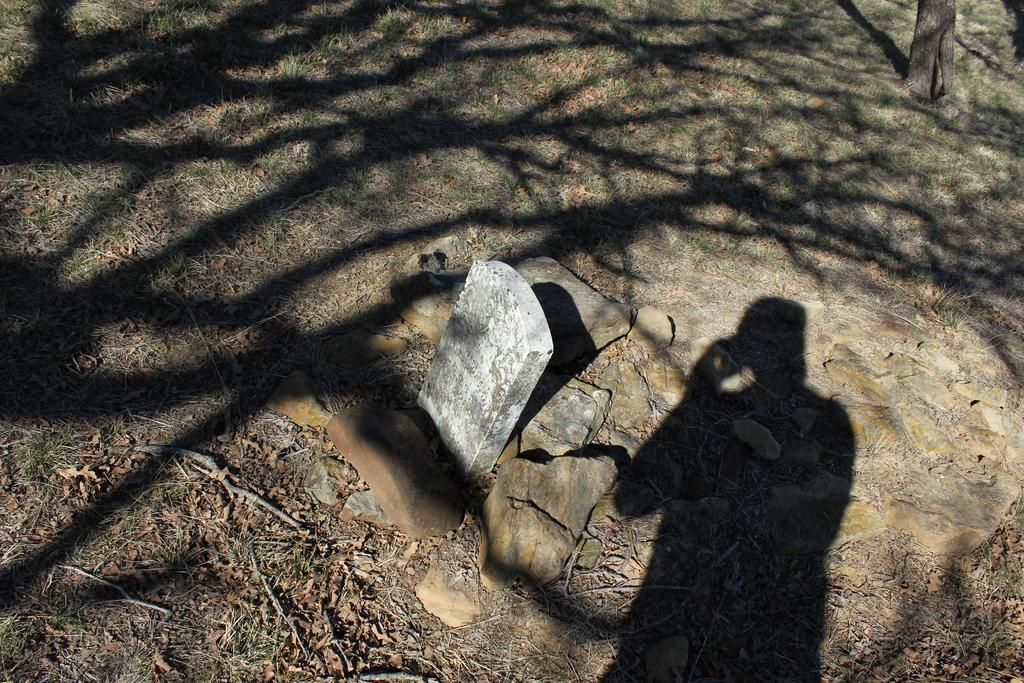What type of location is depicted in the image? There is a cemetery in the image. Where is the cemetery located? The cemetery is on land. What can be found within the cemetery? There are rocks and grass in the cemetery. Is there any vegetation visible in the image? Yes, there is a tree trunk in the top right corner of the image. What type of farm animals can be seen grazing in the afternoon in the image? There is no farm or afternoon depicted in the image; it features a cemetery with rocks, grass, and a tree trunk. 